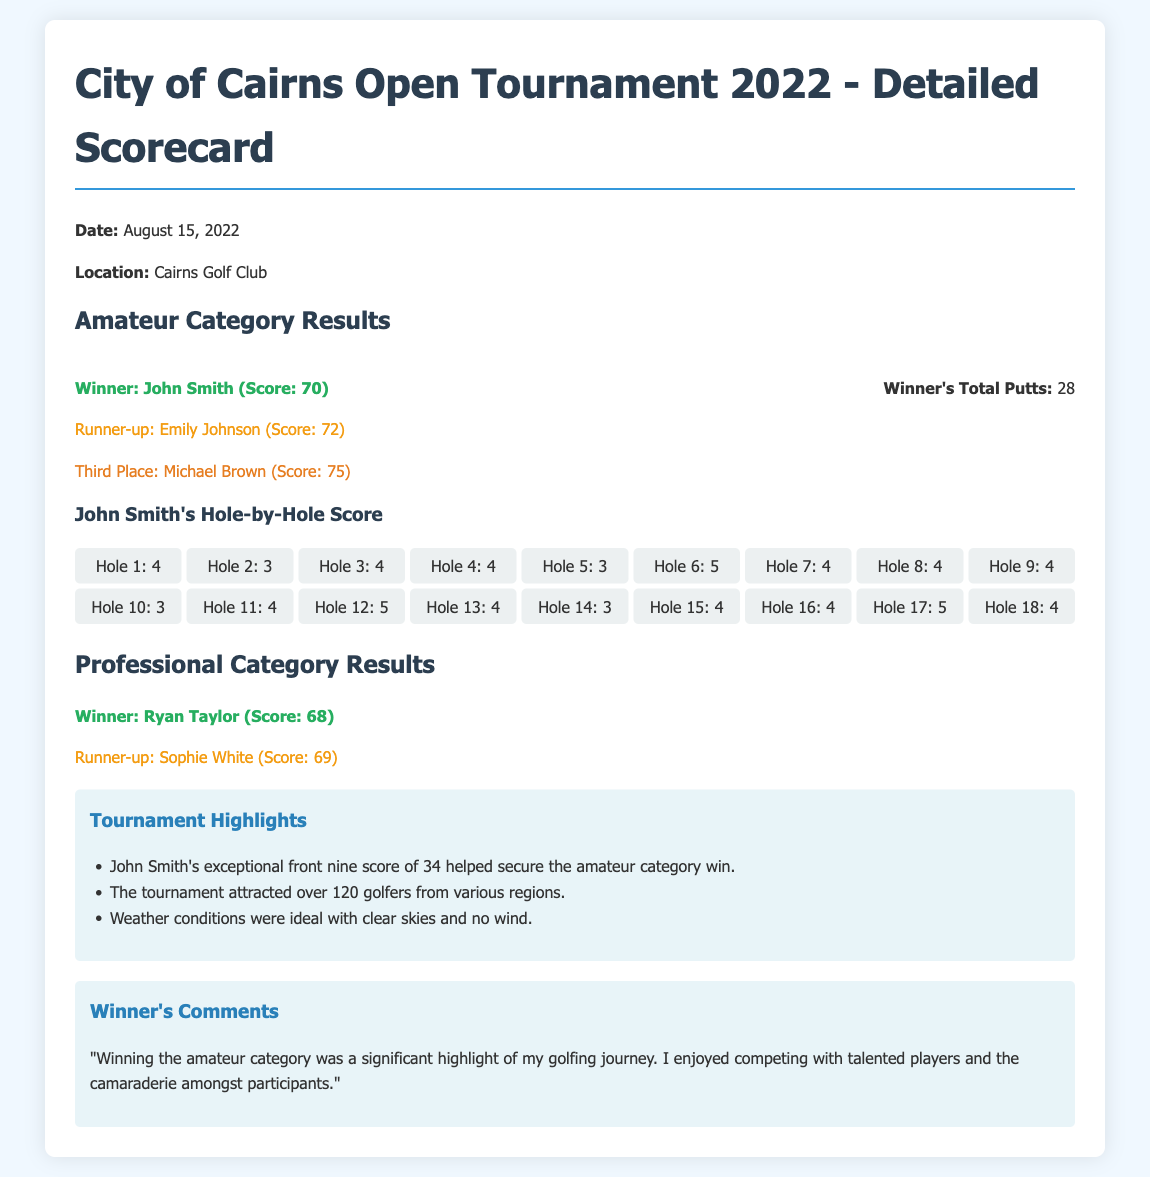What date was the tournament held? The document states that the tournament took place on August 15, 2022.
Answer: August 15, 2022 Who won the amateur category? According to the document, John Smith was the winner of the amateur category.
Answer: John Smith What was John Smith's total score? The document indicates that John Smith scored 70, making him the winner.
Answer: 70 How many putts did the winner have? The document specifies that the winner had a total of 28 putts.
Answer: 28 What was the score of the runner-up in the amateur category? Emily Johnson, the runner-up, received a score of 72 as mentioned in the document.
Answer: 72 What was the score of the winner in the professional category? The document shows that Ryan Taylor won the professional category with a score of 68.
Answer: 68 What was notable about John Smith's front nine score? The highlights mention that John Smith had an exceptional front nine score of 34, which helped him win.
Answer: 34 How many golfers participated in the tournament? The document notes that the tournament attracted over 120 golfers.
Answer: over 120 What did John Smith say about winning the amateur category? The document includes his comment about winning, highlighting it as a significant moment in his golfing journey.
Answer: significant highlight 